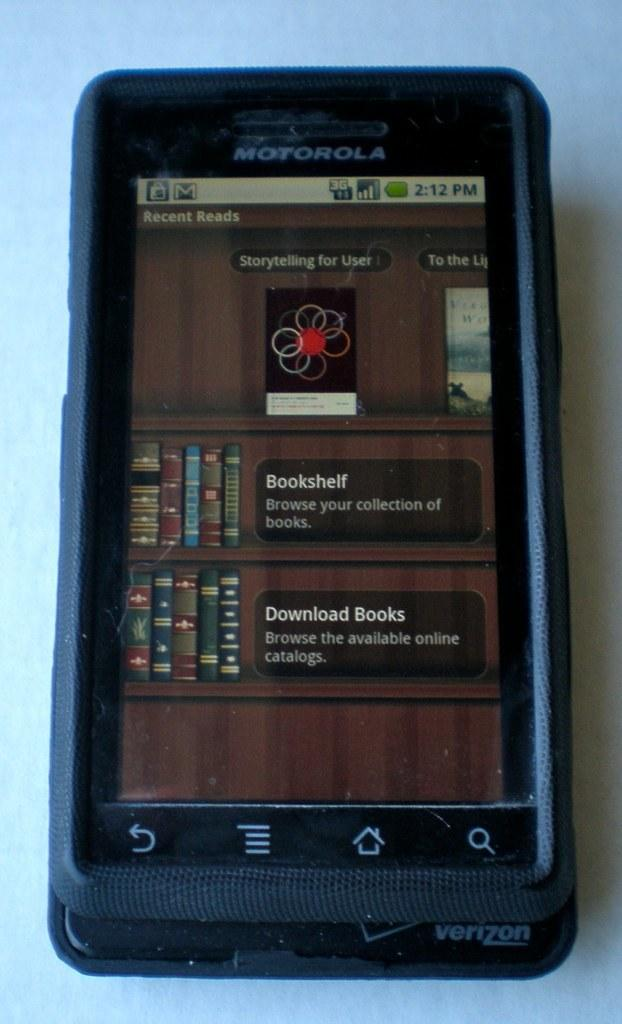<image>
Offer a succinct explanation of the picture presented. A screenshot on a Motorola phone shows a persons downloaded books. 